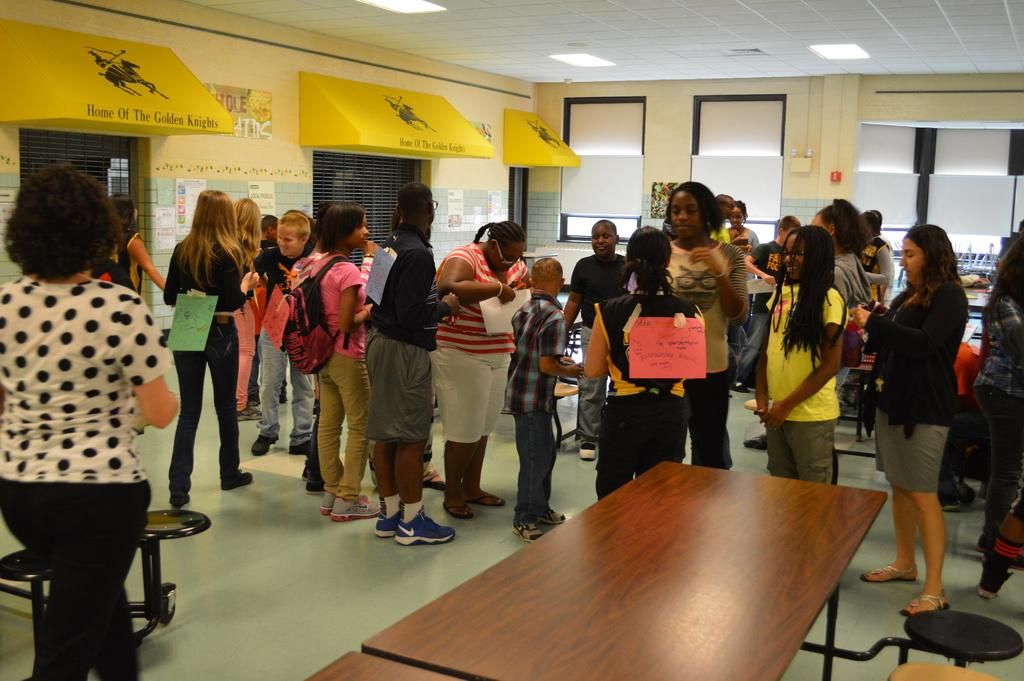How many people are in the image? There is a group of people in the image. Can you describe the clothing of one person in the group? One person in the group is wearing a bag. What can be seen in the background of the image? There are windows visible in the background of the image. How much salt is present on the windows in the image? There is no salt present on the windows in the image. 